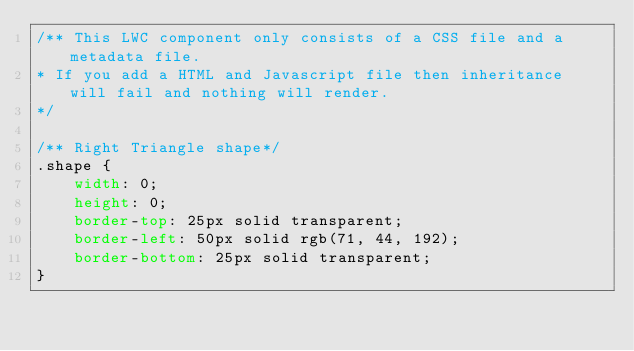<code> <loc_0><loc_0><loc_500><loc_500><_CSS_>/** This LWC component only consists of a CSS file and a metadata file. 
* If you add a HTML and Javascript file then inheritance will fail and nothing will render.
*/

/** Right Triangle shape*/
.shape {
	width: 0;
	height: 0;
	border-top: 25px solid transparent;
	border-left: 50px solid rgb(71, 44, 192);
	border-bottom: 25px solid transparent;
}
</code> 